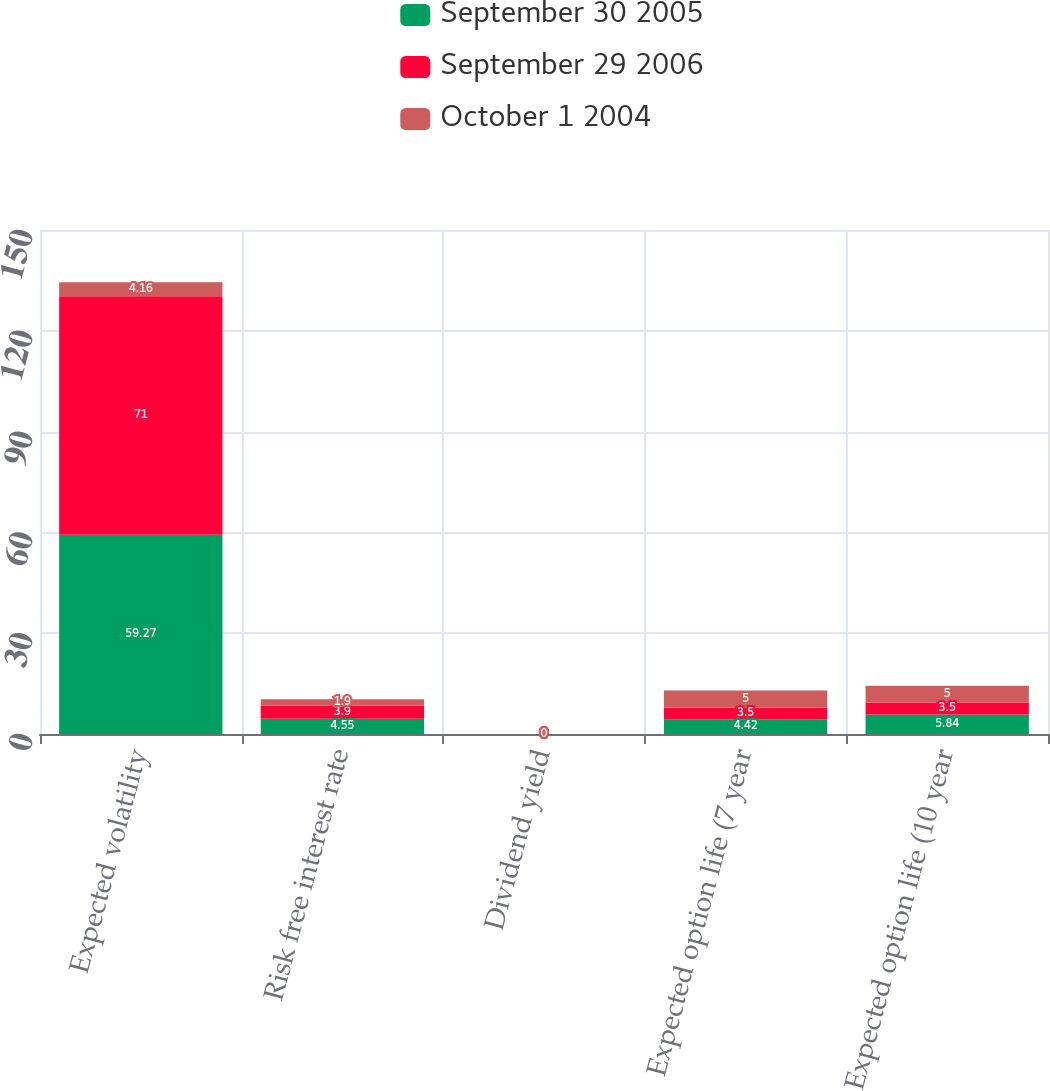Convert chart to OTSL. <chart><loc_0><loc_0><loc_500><loc_500><stacked_bar_chart><ecel><fcel>Expected volatility<fcel>Risk free interest rate<fcel>Dividend yield<fcel>Expected option life (7 year<fcel>Expected option life (10 year<nl><fcel>September 30 2005<fcel>59.27<fcel>4.55<fcel>0<fcel>4.42<fcel>5.84<nl><fcel>September 29 2006<fcel>71<fcel>3.9<fcel>0<fcel>3.5<fcel>3.5<nl><fcel>October 1 2004<fcel>4.16<fcel>1.9<fcel>0<fcel>5<fcel>5<nl></chart> 